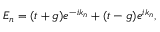Convert formula to latex. <formula><loc_0><loc_0><loc_500><loc_500>E _ { n } = ( t + g ) e ^ { - i k _ { n } } + ( t - g ) e ^ { i k _ { n } } ,</formula> 